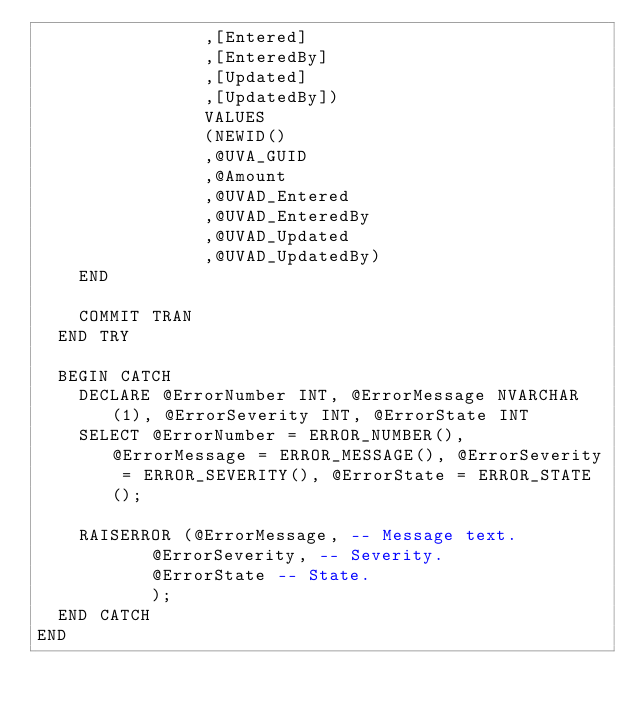Convert code to text. <code><loc_0><loc_0><loc_500><loc_500><_SQL_>								,[Entered]
								,[EnteredBy]
								,[Updated]
								,[UpdatedBy])
								VALUES
								(NEWID()
								,@UVA_GUID
								,@Amount
								,@UVAD_Entered
								,@UVAD_EnteredBy
								,@UVAD_Updated
								,@UVAD_UpdatedBy)
		END

		COMMIT TRAN
	END TRY

	BEGIN CATCH
		DECLARE @ErrorNumber INT, @ErrorMessage NVARCHAR(1), @ErrorSeverity INT, @ErrorState INT
		SELECT @ErrorNumber = ERROR_NUMBER(), @ErrorMessage = ERROR_MESSAGE(), @ErrorSeverity = ERROR_SEVERITY(), @ErrorState = ERROR_STATE();
	
		RAISERROR (@ErrorMessage, -- Message text.  
				   @ErrorSeverity, -- Severity.  
				   @ErrorState -- State.  
				   ); 
	END CATCH
END</code> 